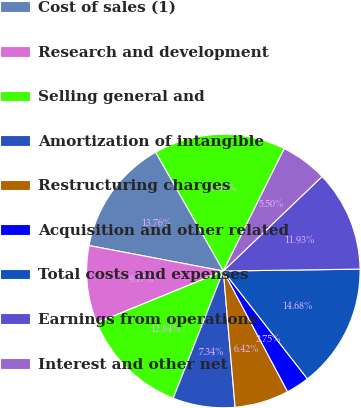<chart> <loc_0><loc_0><loc_500><loc_500><pie_chart><fcel>Net revenue<fcel>Cost of sales (1)<fcel>Research and development<fcel>Selling general and<fcel>Amortization of intangible<fcel>Restructuring charges<fcel>Acquisition and other related<fcel>Total costs and expenses<fcel>Earnings from operations<fcel>Interest and other net<nl><fcel>15.6%<fcel>13.76%<fcel>9.17%<fcel>12.84%<fcel>7.34%<fcel>6.42%<fcel>2.75%<fcel>14.68%<fcel>11.93%<fcel>5.5%<nl></chart> 